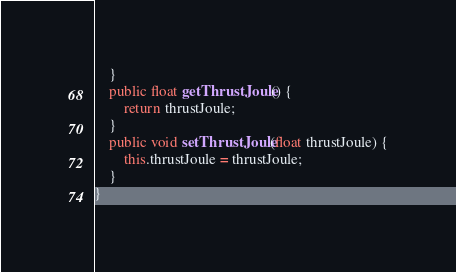Convert code to text. <code><loc_0><loc_0><loc_500><loc_500><_Java_>	}
	public float getThrustJoule() {
		return thrustJoule;
	}
	public void setThrustJoule(float thrustJoule) {
		this.thrustJoule = thrustJoule;
	}	
}
</code> 